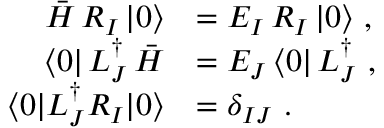Convert formula to latex. <formula><loc_0><loc_0><loc_500><loc_500>\begin{array} { r l } { \bar { H } \, R _ { I } \, | 0 \rangle } & { = E _ { I } \, R _ { I } \, | 0 \rangle , } \\ { \langle 0 | \, L _ { J } ^ { \dagger } \, \bar { H } } & { = E _ { J } \, \langle 0 | \, L _ { J } ^ { \dagger } , } \\ { \langle 0 | L _ { J } ^ { \dagger } R _ { I } | 0 \rangle } & { = \delta _ { I J } . } \end{array}</formula> 